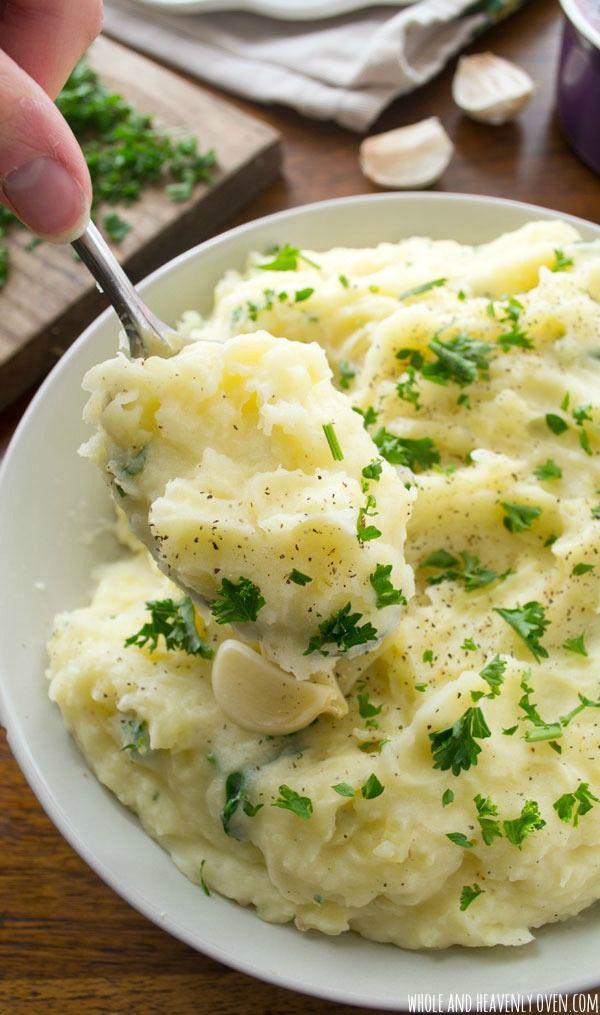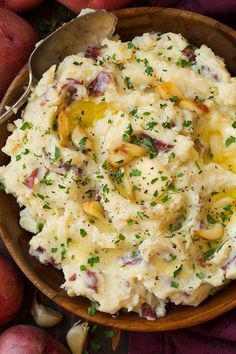The first image is the image on the left, the second image is the image on the right. Analyze the images presented: Is the assertion "An item of silverware is on a napkin next to a round white bowl containing food." valid? Answer yes or no. No. The first image is the image on the left, the second image is the image on the right. Evaluate the accuracy of this statement regarding the images: "In one of the images, there is a piece of silverware on table next to the food dish, and no silverware in the food itself.". Is it true? Answer yes or no. No. 